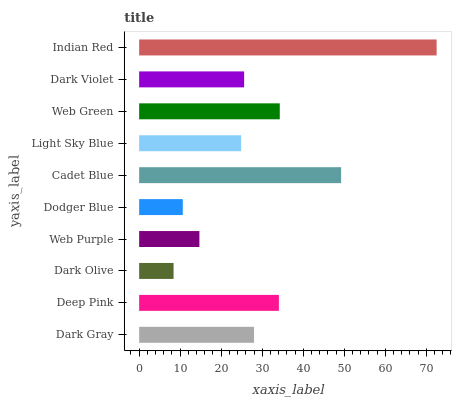Is Dark Olive the minimum?
Answer yes or no. Yes. Is Indian Red the maximum?
Answer yes or no. Yes. Is Deep Pink the minimum?
Answer yes or no. No. Is Deep Pink the maximum?
Answer yes or no. No. Is Deep Pink greater than Dark Gray?
Answer yes or no. Yes. Is Dark Gray less than Deep Pink?
Answer yes or no. Yes. Is Dark Gray greater than Deep Pink?
Answer yes or no. No. Is Deep Pink less than Dark Gray?
Answer yes or no. No. Is Dark Gray the high median?
Answer yes or no. Yes. Is Dark Violet the low median?
Answer yes or no. Yes. Is Dodger Blue the high median?
Answer yes or no. No. Is Web Green the low median?
Answer yes or no. No. 